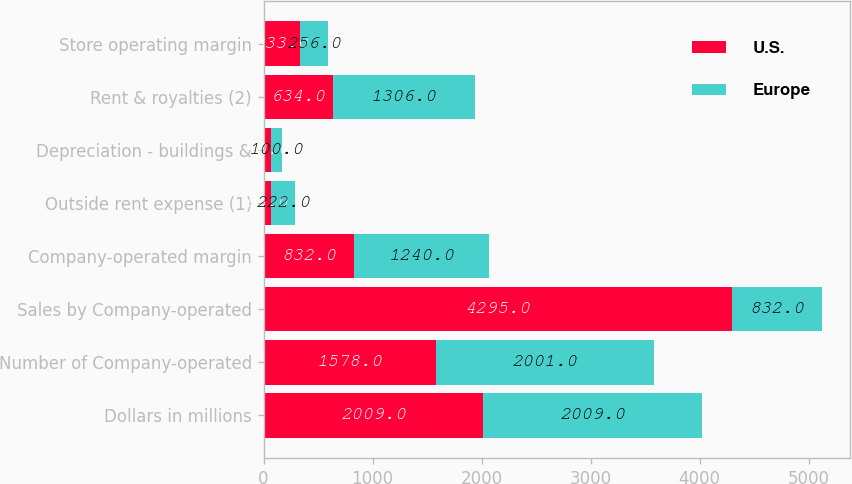<chart> <loc_0><loc_0><loc_500><loc_500><stacked_bar_chart><ecel><fcel>Dollars in millions<fcel>Number of Company-operated<fcel>Sales by Company-operated<fcel>Company-operated margin<fcel>Outside rent expense (1)<fcel>Depreciation - buildings &<fcel>Rent & royalties (2)<fcel>Store operating margin<nl><fcel>U.S.<fcel>2009<fcel>1578<fcel>4295<fcel>832<fcel>65<fcel>70<fcel>634<fcel>333<nl><fcel>Europe<fcel>2009<fcel>2001<fcel>832<fcel>1240<fcel>222<fcel>100<fcel>1306<fcel>256<nl></chart> 